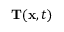Convert formula to latex. <formula><loc_0><loc_0><loc_500><loc_500>{ \mathbf T } ( { \mathbf x } , t )</formula> 